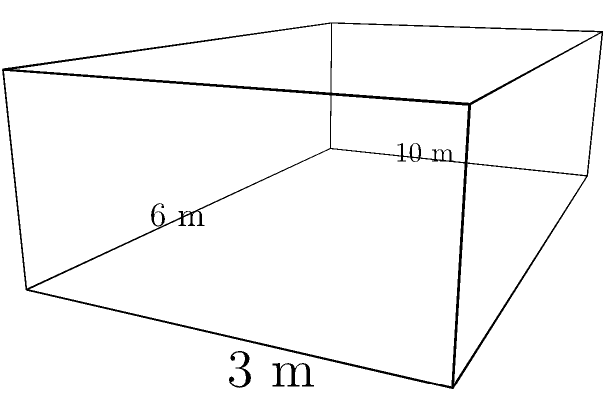For the upcoming choral festival, you need to design a rectangular prism-shaped stage. The stage dimensions are 10 meters long, 6 meters wide, and 3 meters high. What is the volume of the stage in cubic meters? To calculate the volume of a rectangular prism, we use the formula:

$$ V = l \times w \times h $$

Where:
$V$ = volume
$l$ = length
$w$ = width
$h$ = height

Given dimensions:
Length ($l$) = 10 meters
Width ($w$) = 6 meters
Height ($h$) = 3 meters

Substituting these values into the formula:

$$ V = 10 \times 6 \times 3 $$

$$ V = 180 $$

Therefore, the volume of the stage is 180 cubic meters.
Answer: 180 m³ 